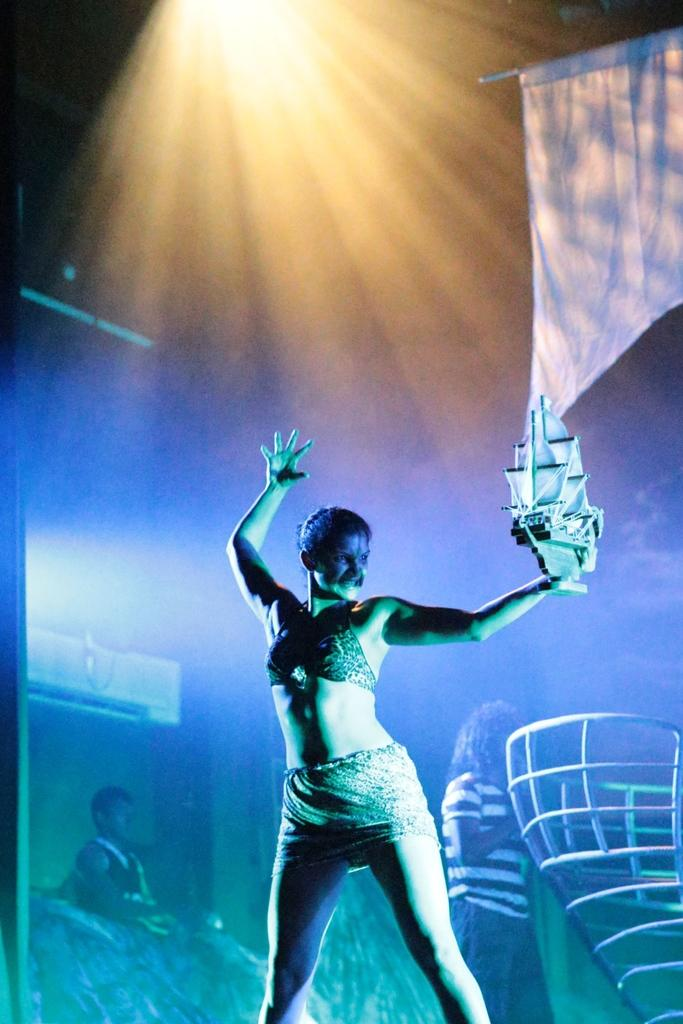What is the person in the image doing? The person is standing and holding something in the image. Can you describe the scene in the background? There are people visible in the background of the image, along with a white flag. What colors of lighting can be seen in the background of the image? There is purple, green, yellow, and white color lighting in the background of the image. How many chairs are visible in the image? There are no chairs visible in the image. What type of grip does the person have on the object they are holding? The image does not provide enough detail to determine the type of grip the person has on the object they are holding. 